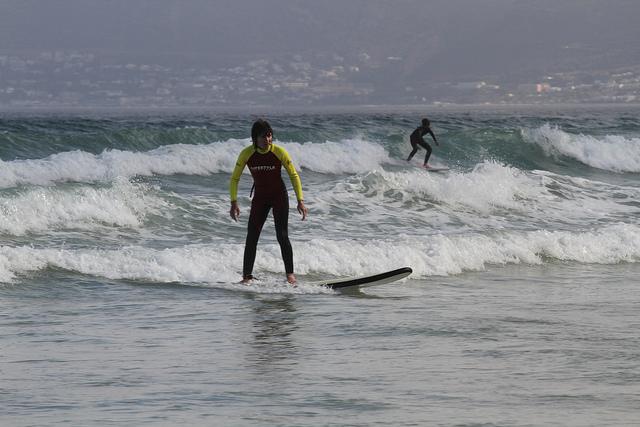Could this water be chilly?
Short answer required. Yes. Are these people surfing in the ocean?
Answer briefly. Yes. Are they practicing a sport?
Give a very brief answer. Yes. How choppy is the water?
Short answer required. Very. What color is the person's wetsuit?
Short answer required. Yellow and black. What do you call this type of sport?
Answer briefly. Surfing. What is the person holding?
Quick response, please. Nothing. Is there more than one person in the water?
Quick response, please. Yes. Is the surfer going to fall?
Quick response, please. No. 